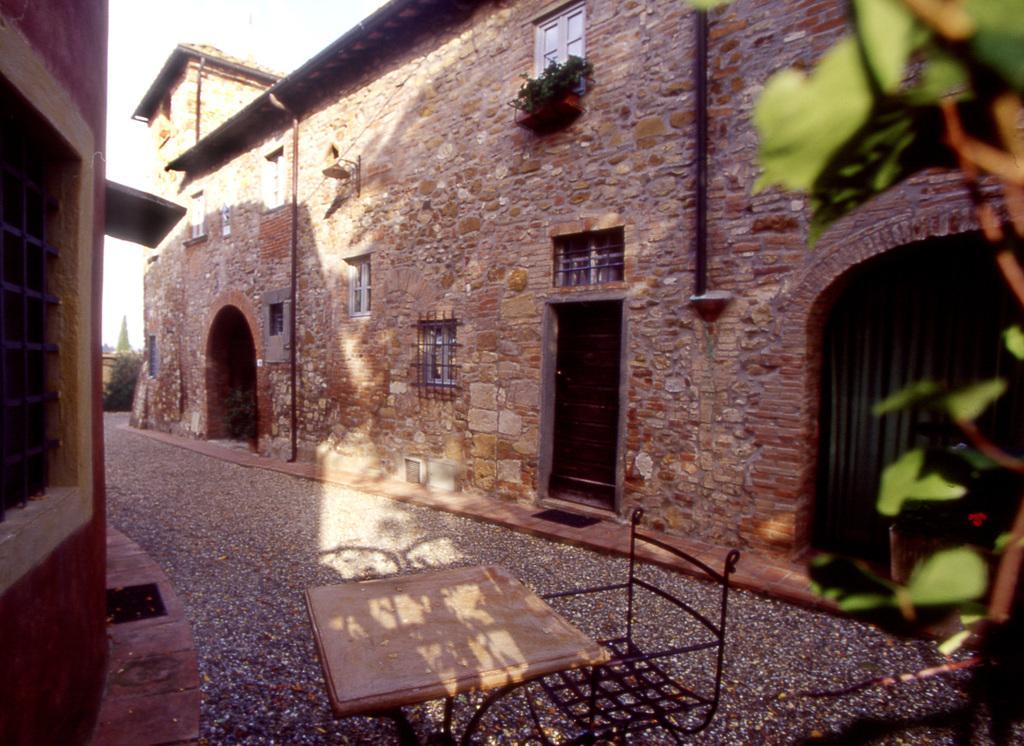Could you give a brief overview of what you see in this image? At the bottom, it is a table and a chair and these are the stone walls. 